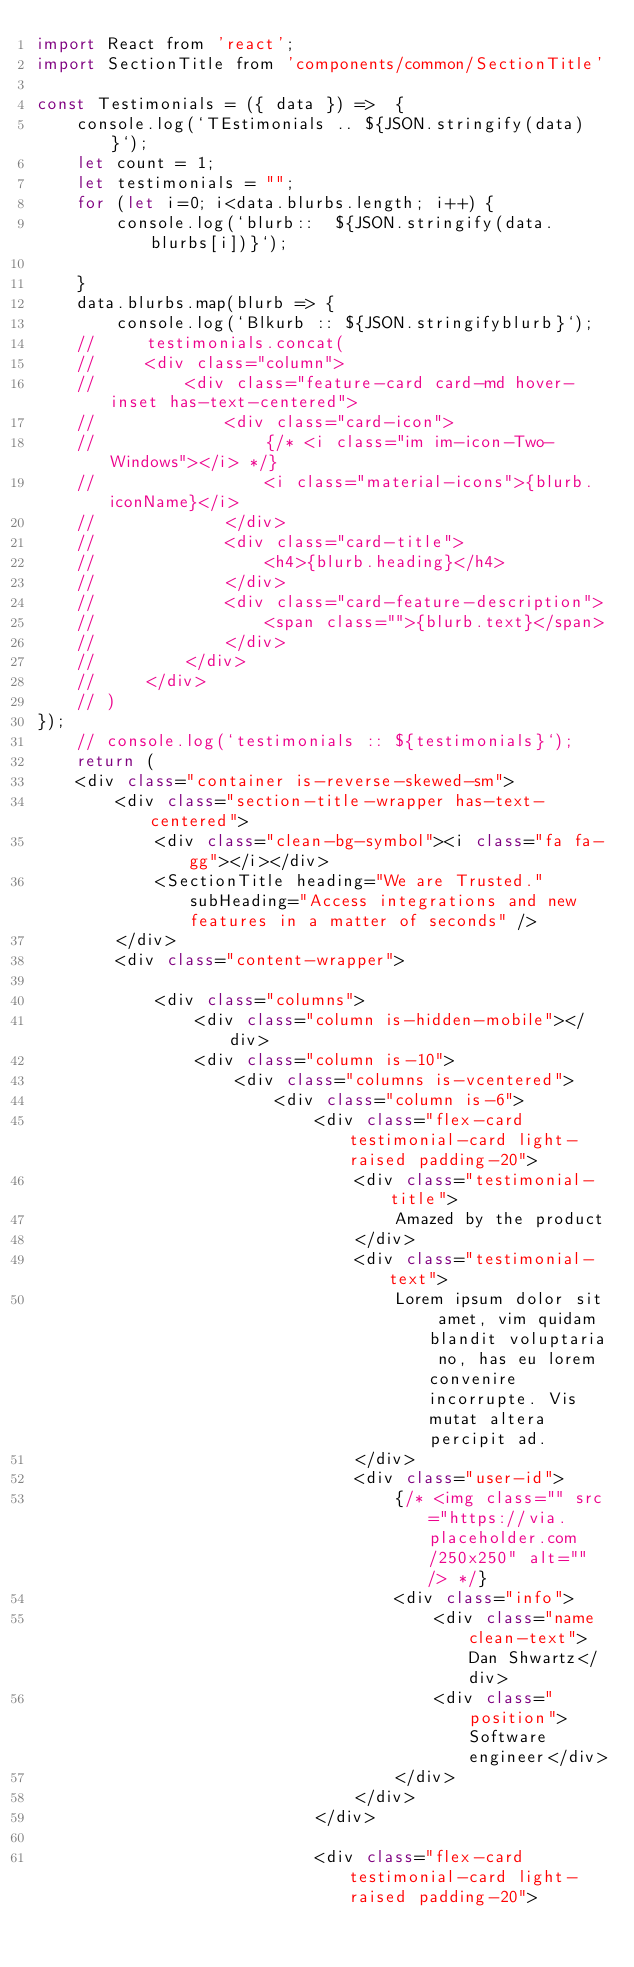Convert code to text. <code><loc_0><loc_0><loc_500><loc_500><_JavaScript_>import React from 'react';
import SectionTitle from 'components/common/SectionTitle'

const Testimonials = ({ data }) =>  { 
    console.log(`TEstimonials .. ${JSON.stringify(data)}`);
    let count = 1;
    let testimonials = "";
    for (let i=0; i<data.blurbs.length; i++) {
        console.log(`blurb::  ${JSON.stringify(data.blurbs[i])}`);

    }
    data.blurbs.map(blurb => {
        console.log(`Blkurb :: ${JSON.stringifyblurb}`);
    //     testimonials.concat(
    //     <div class="column">
    //         <div class="feature-card card-md hover-inset has-text-centered">
    //             <div class="card-icon">
    //                 {/* <i class="im im-icon-Two-Windows"></i> */}
    //                 <i class="material-icons">{blurb.iconName}</i>
    //             </div>
    //             <div class="card-title">
    //                 <h4>{blurb.heading}</h4>
    //             </div>
    //             <div class="card-feature-description">
    //                 <span class="">{blurb.text}</span>
    //             </div>
    //         </div>
    //     </div>
    // )
});
    // console.log(`testimonials :: ${testimonials}`);
    return (
    <div class="container is-reverse-skewed-sm">
        <div class="section-title-wrapper has-text-centered">
            <div class="clean-bg-symbol"><i class="fa fa-gg"></i></div>
            <SectionTitle heading="We are Trusted." subHeading="Access integrations and new features in a matter of seconds" />    
        </div>
        <div class="content-wrapper">
            
            <div class="columns">
                <div class="column is-hidden-mobile"></div>
                <div class="column is-10">
                    <div class="columns is-vcentered">
                        <div class="column is-6">
                            <div class="flex-card testimonial-card light-raised padding-20">
                                <div class="testimonial-title">
                                    Amazed by the product
                                </div>
                                <div class="testimonial-text">
                                    Lorem ipsum dolor sit amet, vim quidam blandit voluptaria no, has eu lorem convenire incorrupte. Vis mutat altera percipit ad.
                                </div>
                                <div class="user-id">
                                    {/* <img class="" src="https://via.placeholder.com/250x250" alt="" /> */}
                                    <div class="info">
                                        <div class="name clean-text">Dan Shwartz</div>
                                        <div class="position">Software engineer</div>
                                    </div>
                                </div>
                            </div>
                            
                            <div class="flex-card testimonial-card light-raised padding-20"></code> 